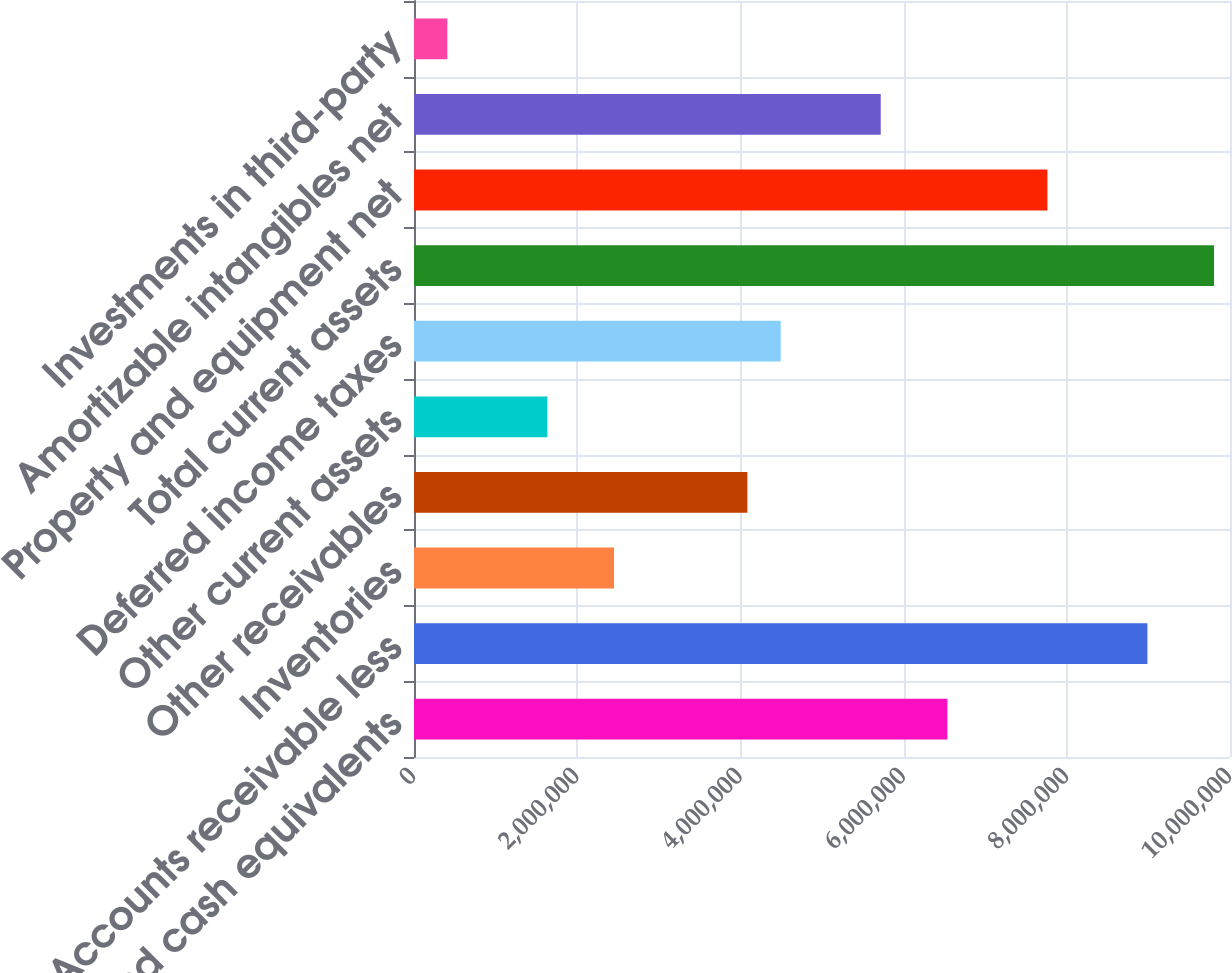Convert chart. <chart><loc_0><loc_0><loc_500><loc_500><bar_chart><fcel>Cash and cash equivalents<fcel>Accounts receivable less<fcel>Inventories<fcel>Other receivables<fcel>Other current assets<fcel>Deferred income taxes<fcel>Total current assets<fcel>Property and equipment net<fcel>Amortizable intangibles net<fcel>Investments in third-party<nl><fcel>6.53662e+06<fcel>8.9878e+06<fcel>2.45132e+06<fcel>4.08544e+06<fcel>1.63426e+06<fcel>4.49396e+06<fcel>9.80486e+06<fcel>7.7622e+06<fcel>5.71956e+06<fcel>408665<nl></chart> 